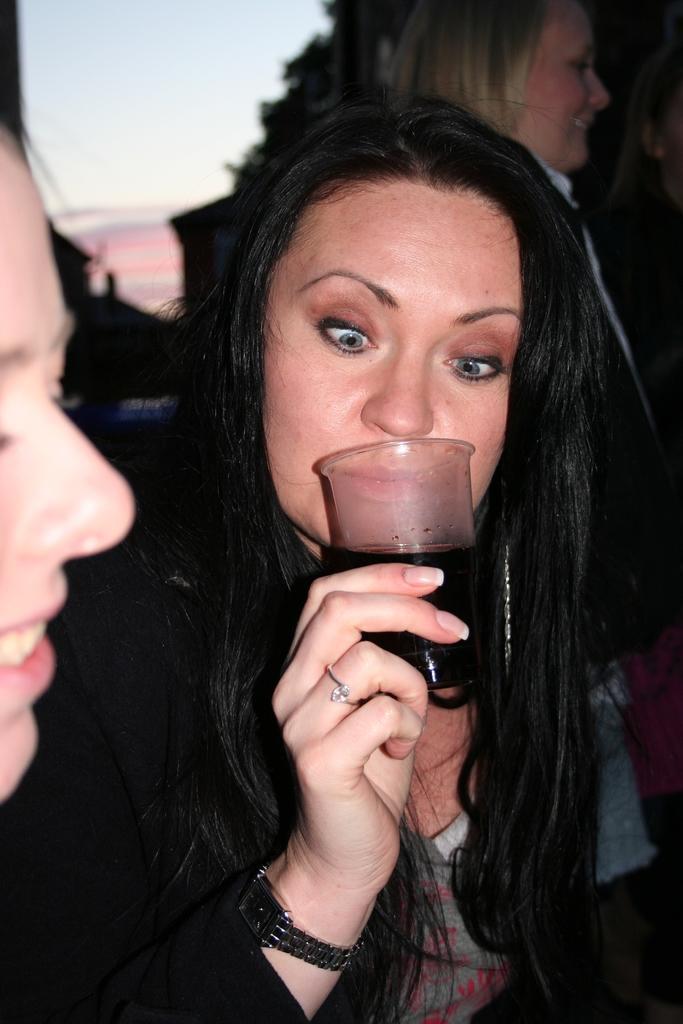How would you summarize this image in a sentence or two? In this image we can see a woman holding a glass with liquid in it. In the background we can see persons, clouds in the sky and trees. On the left side we can see persons face. 